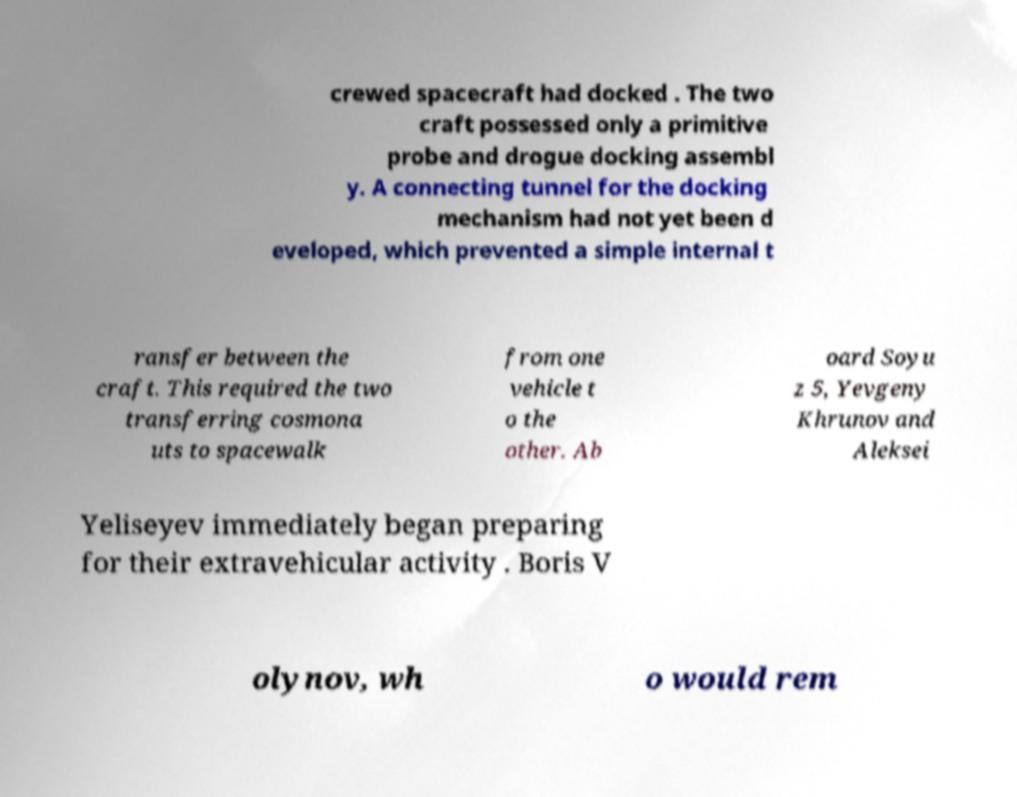I need the written content from this picture converted into text. Can you do that? crewed spacecraft had docked . The two craft possessed only a primitive probe and drogue docking assembl y. A connecting tunnel for the docking mechanism had not yet been d eveloped, which prevented a simple internal t ransfer between the craft. This required the two transferring cosmona uts to spacewalk from one vehicle t o the other. Ab oard Soyu z 5, Yevgeny Khrunov and Aleksei Yeliseyev immediately began preparing for their extravehicular activity . Boris V olynov, wh o would rem 